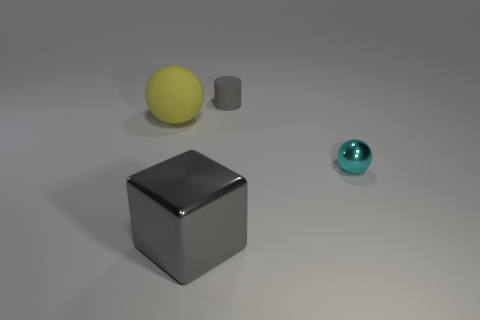What could be the function of these objects if they were not simple geometric shapes? If these were functional objects rather than geometric shapes, the large cube could serve as a storage box, the sphere might be a decorative ball or a light fixture depending on its material, the tiny cylinder could be a container or a stand, and the small sphere might serve as a paperweight or an ornamental desk object. 